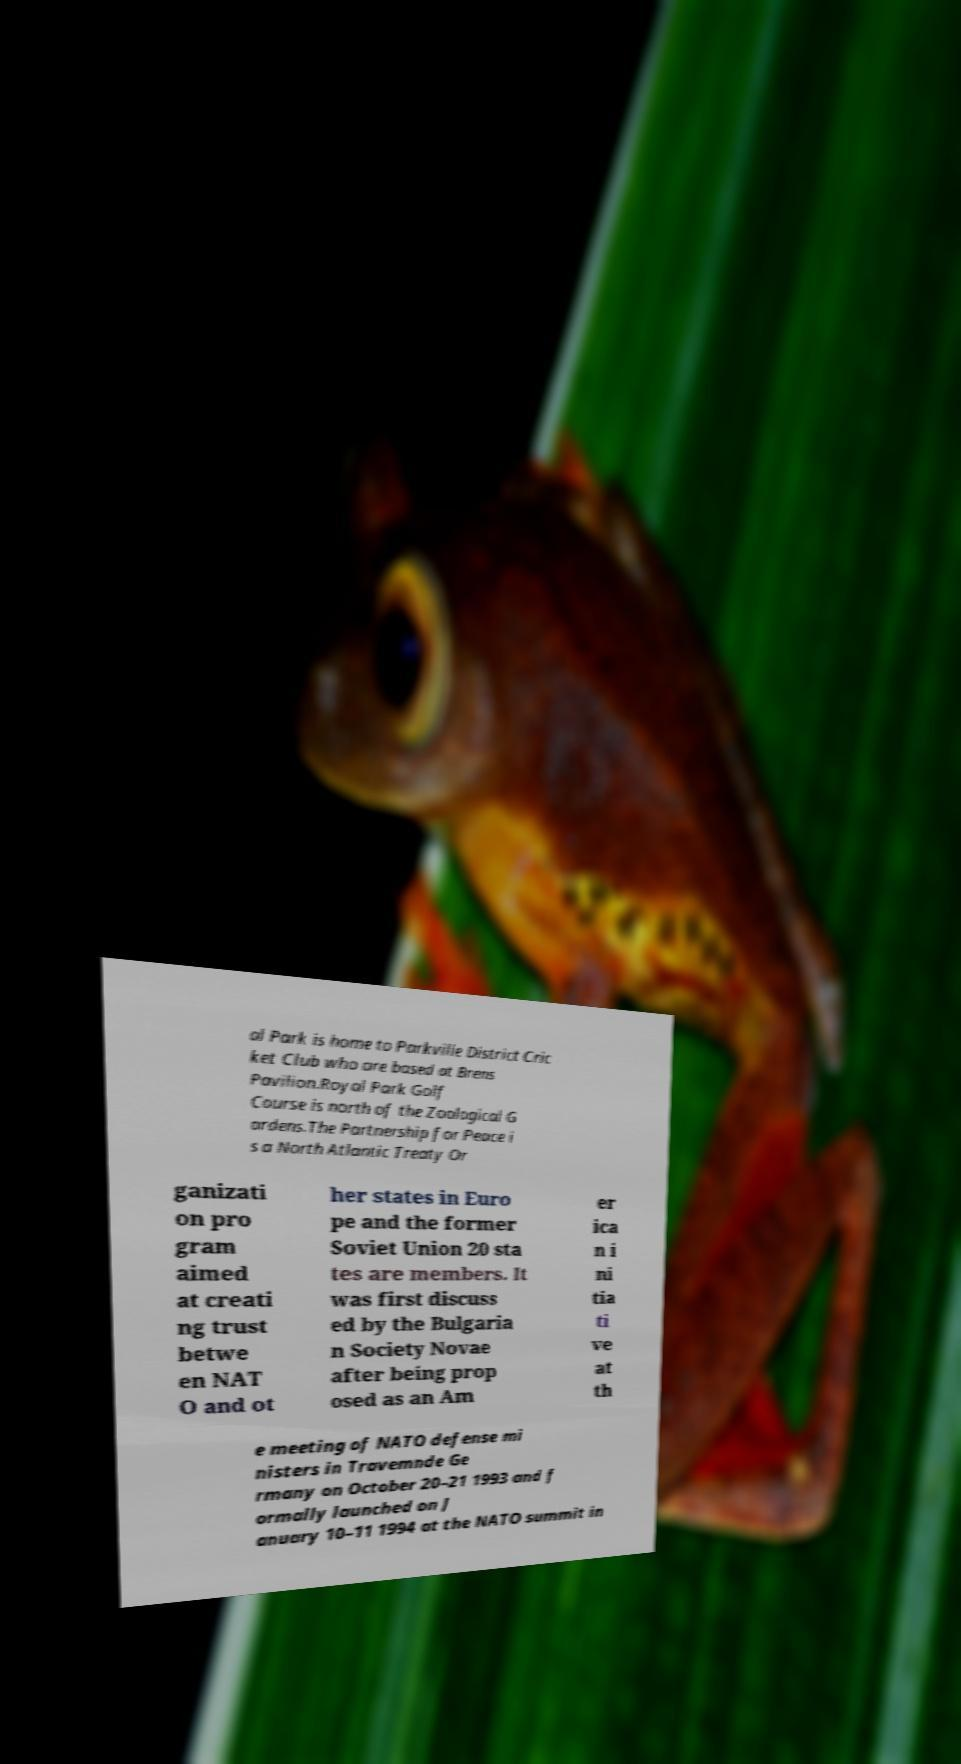Could you extract and type out the text from this image? al Park is home to Parkville District Cric ket Club who are based at Brens Pavilion.Royal Park Golf Course is north of the Zoological G ardens.The Partnership for Peace i s a North Atlantic Treaty Or ganizati on pro gram aimed at creati ng trust betwe en NAT O and ot her states in Euro pe and the former Soviet Union 20 sta tes are members. It was first discuss ed by the Bulgaria n Society Novae after being prop osed as an Am er ica n i ni tia ti ve at th e meeting of NATO defense mi nisters in Travemnde Ge rmany on October 20–21 1993 and f ormally launched on J anuary 10–11 1994 at the NATO summit in 